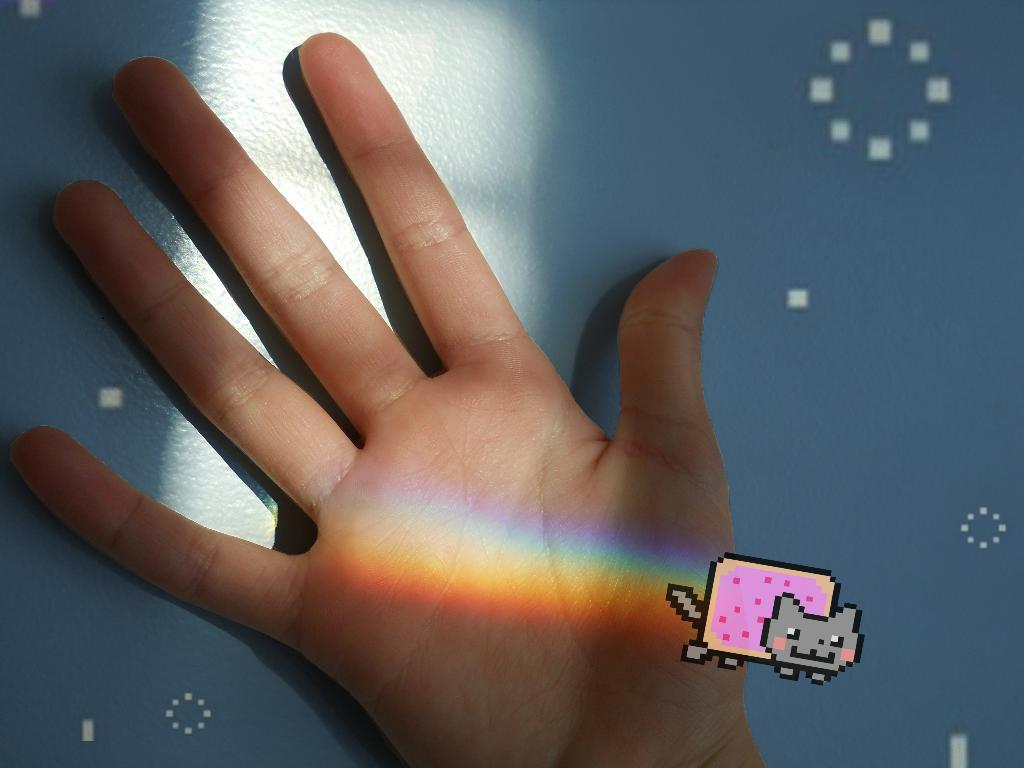What is the main feature of the image? There is a rainbow in the image. Where is the rainbow located? The rainbow is on a hand. What color is the background of the image? The background of the image is blue. What type of copper cannon is visible in the image? There is no copper cannon present in the image; it features a rainbow on a hand with a blue background. How does the beam of light interact with the rainbow in the image? There is no beam of light present in the image; it only features a rainbow on a hand with a blue background. 